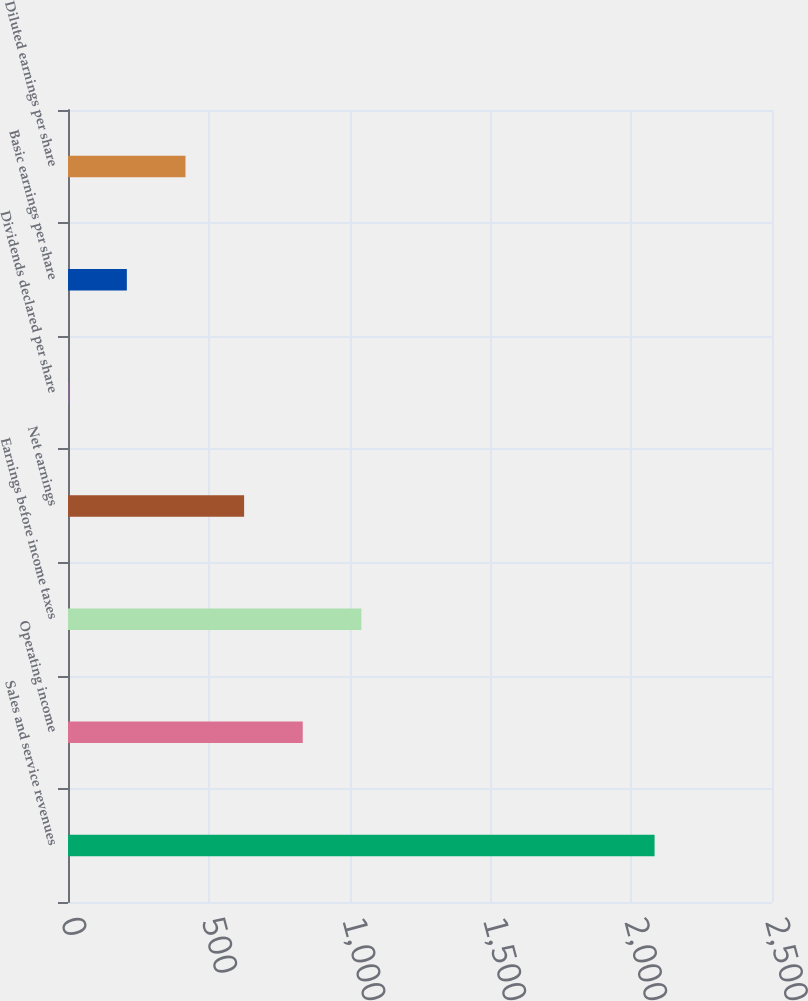Convert chart to OTSL. <chart><loc_0><loc_0><loc_500><loc_500><bar_chart><fcel>Sales and service revenues<fcel>Operating income<fcel>Earnings before income taxes<fcel>Net earnings<fcel>Dividends declared per share<fcel>Basic earnings per share<fcel>Diluted earnings per share<nl><fcel>2083<fcel>833.64<fcel>1041.87<fcel>625.41<fcel>0.72<fcel>208.95<fcel>417.18<nl></chart> 